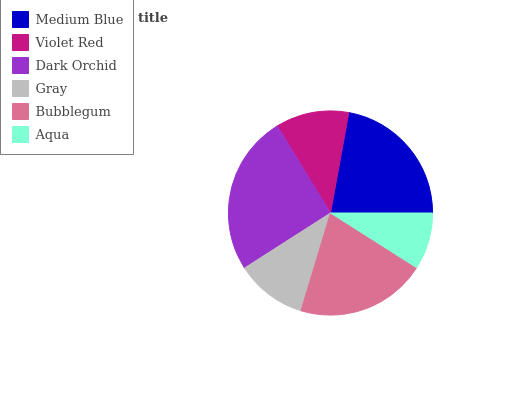Is Aqua the minimum?
Answer yes or no. Yes. Is Dark Orchid the maximum?
Answer yes or no. Yes. Is Violet Red the minimum?
Answer yes or no. No. Is Violet Red the maximum?
Answer yes or no. No. Is Medium Blue greater than Violet Red?
Answer yes or no. Yes. Is Violet Red less than Medium Blue?
Answer yes or no. Yes. Is Violet Red greater than Medium Blue?
Answer yes or no. No. Is Medium Blue less than Violet Red?
Answer yes or no. No. Is Bubblegum the high median?
Answer yes or no. Yes. Is Violet Red the low median?
Answer yes or no. Yes. Is Medium Blue the high median?
Answer yes or no. No. Is Dark Orchid the low median?
Answer yes or no. No. 